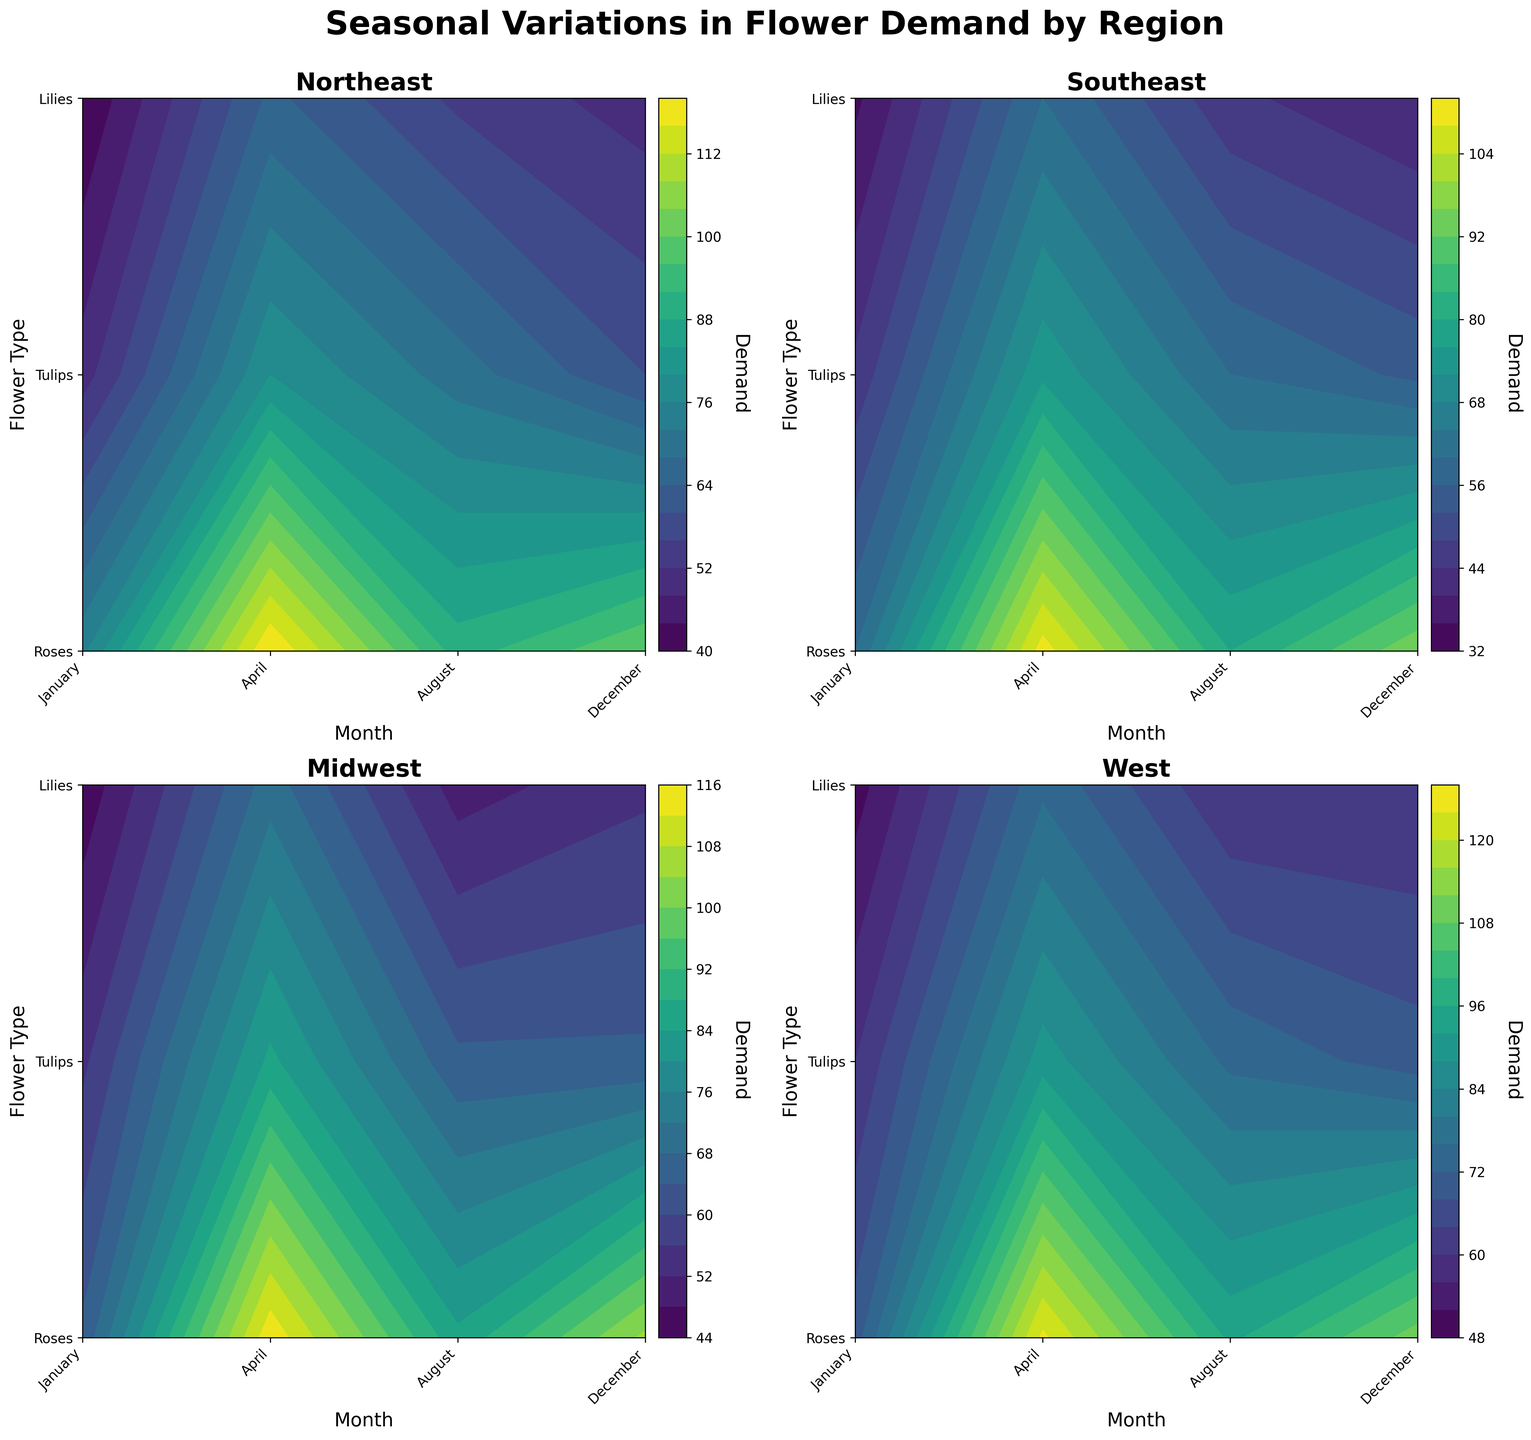Which flower type shows the highest demand in April in the West region? By examining the contour plot for the West region, we can see that the demand for each flower type in April is indicated by the highest contour levels (color intensities). In this region, Roses show the highest demand in April.
Answer: Roses Which month sees the lowest demand for Tulips in the Southeast region? Observing the Southeast region's subplot, the demand levels for Tulips across months are compared. January exhibits the lowest contour level (lightest color) for Tulips, indicating the lowest demand.
Answer: January How does the demand for Lilies in the Northeast region in August compare to December? In the plot for the Northeast region, the contour levels for Lilies in August and December can be compared. We observe that August shows a slightly lighter contour (lower demand) for Lilies compared to December.
Answer: Lower in August What is the general trend of Rose demand across all regions in April? By reviewing the subplots for each region, all regions exhibit a peak in demand for Roses during April, indicated by the darkest colors and highest contour levels in that month. This suggests a general high demand for Roses in April across all regions.
Answer: High demand in April Which region shows the most significant increase in demand for Tulips from January to April? By comparing the contour plots for January and April for each region, the West region shows the most dramatic change, with demand for Tulips transitioning from lighter to darker colors, indicating a significant increase.
Answer: West Do wedding seasons affect the demand for flowers uniformly across all regions? The subplot analysis reveals that April, a common wedding season month, consistently shows high demand for flowers across all regions, suggesting a strong influence of wedding seasons uniformly.
Answer: Yes Which flower type has the least variation in demand throughout the year in the Midwest region? By inspecting the contour levels for all months, Lilies exhibit the most consistent (less varying) contour colors compared to Roses and Tulips in the Midwest region.
Answer: Lilies What special event tends to spike Rose demand in December in any region? Examining the contour plots reveals evident peaks in Rose demand in December across regions, likely due to increased purchases for holiday celebrations.
Answer: Holidays 